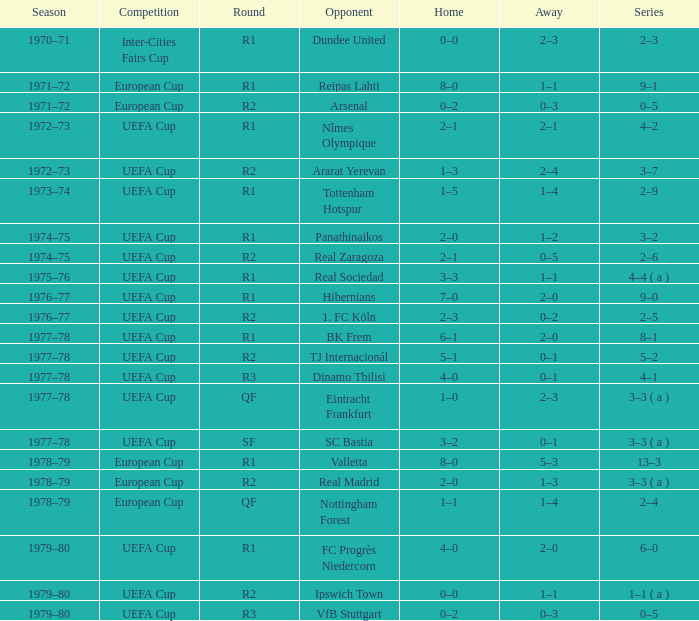Which residence has a cycle of r1, and an adversary of dundee united? 0–0. 